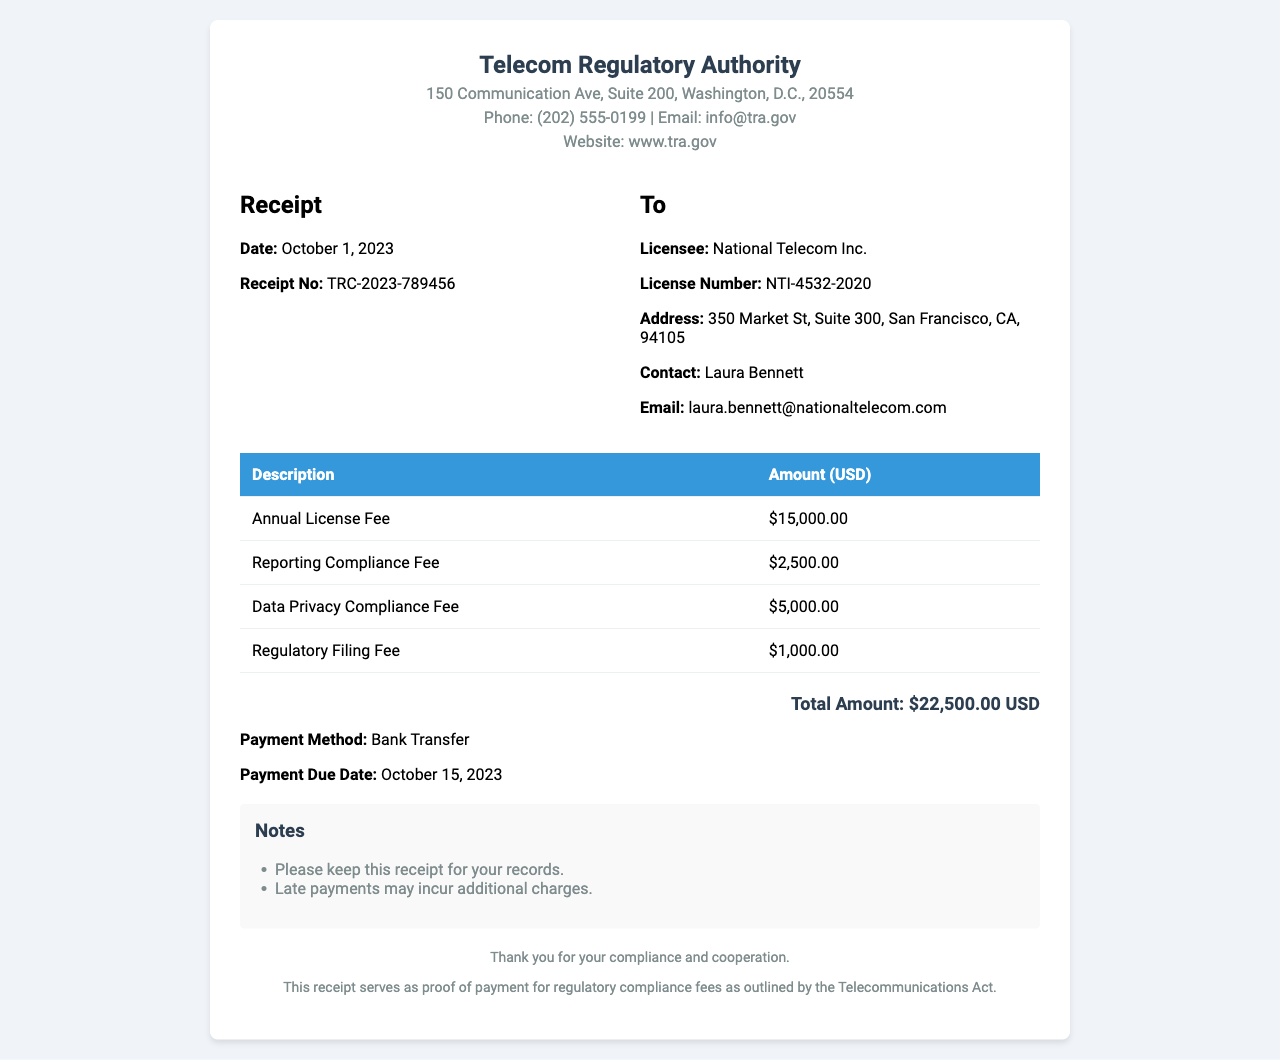What is the date of the receipt? The date of the receipt is clearly stated in the document, which is October 1, 2023.
Answer: October 1, 2023 What is the receipt number? The receipt number is specified in the document as TRC-2023-789456.
Answer: TRC-2023-789456 What is the total amount due? The total amount due is the sum of all charges listed in the receipt, which is $22,500.00.
Answer: $22,500.00 Who is the licensee? The licensee's name is provided in the document as National Telecom Inc.
Answer: National Telecom Inc When is the payment due? The payment due date is mentioned in the receipt, which is October 15, 2023.
Answer: October 15, 2023 What are the components of the total amount? The document lists various charges contributing to the total amount, which include the Annual License Fee, Reporting Compliance Fee, Data Privacy Compliance Fee, and Regulatory Filing Fee.
Answer: Annual License Fee, Reporting Compliance Fee, Data Privacy Compliance Fee, Regulatory Filing Fee What is the payment method? The receipt specifies that the payment method is Bank Transfer.
Answer: Bank Transfer What is the address of the Telecom Regulatory Authority? The address for the Telecom Regulatory Authority is detailed as 150 Communication Ave, Suite 200, Washington, D.C., 20554.
Answer: 150 Communication Ave, Suite 200, Washington, D.C., 20554 What note is included regarding late payments? The document mentions that late payments may incur additional charges.
Answer: Late payments may incur additional charges 